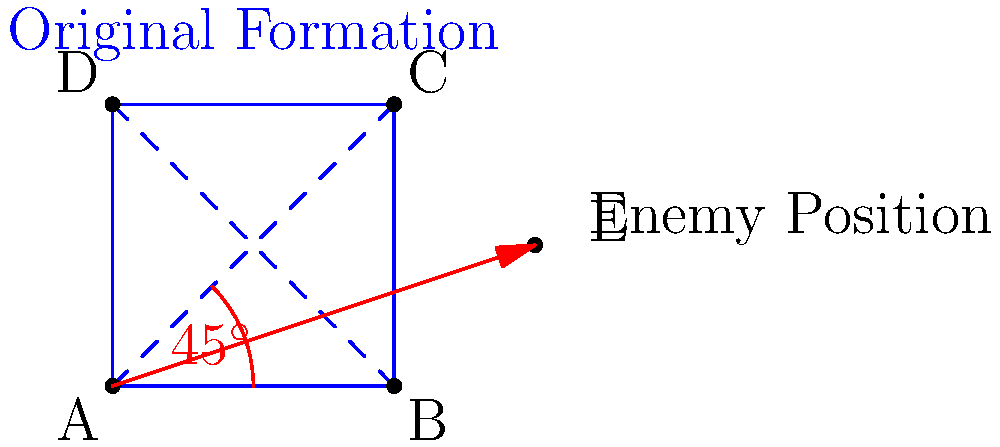A square military formation ABCD needs to rotate 45° counterclockwise around point A to flank an enemy position at E. What are the coordinates of point C after the rotation? To solve this problem, we'll use the rotation formula for a point (x,y) around the origin (0,0) by an angle θ:

x' = x cos θ - y sin θ
y' = x sin θ + y cos θ

Steps:
1. Identify the initial coordinates of point C: (2,2)
2. The rotation angle is 45° counterclockwise, so θ = 45°
3. The rotation is around point A (0,0), so we can use the origin rotation formula
4. Calculate sin 45° and cos 45°:
   sin 45° = cos 45° = $\frac{1}{\sqrt{2}} \approx 0.7071$
5. Apply the rotation formula:
   x' = 2 cos 45° - 2 sin 45° = 2($\frac{1}{\sqrt{2}}) - 2($\frac{1}{\sqrt{2}}) = 0
   y' = 2 sin 45° + 2 cos 45° = 2($\frac{1}{\sqrt{2}}) + 2($\frac{1}{\sqrt{2}}) = 2$\sqrt{2}$ ≈ 2.8284
6. The new coordinates of point C after rotation are (0, 2$\sqrt{2}$)
Answer: (0, 2$\sqrt{2}$) 